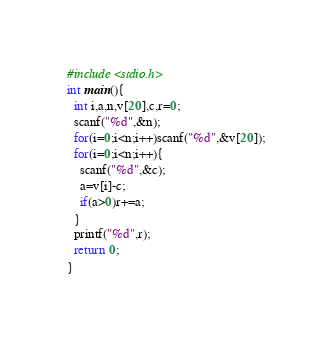<code> <loc_0><loc_0><loc_500><loc_500><_C_>#include <stdio.h>
int main(){
  int i,a,n,v[20],c,r=0;
  scanf("%d",&n);
  for(i=0;i<n;i++)scanf("%d",&v[20]);
  for(i=0;i<n;i++){
    scanf("%d",&c);
    a=v[i]-c;
    if(a>0)r+=a;
  }
  printf("%d",r);
  return 0;
}</code> 